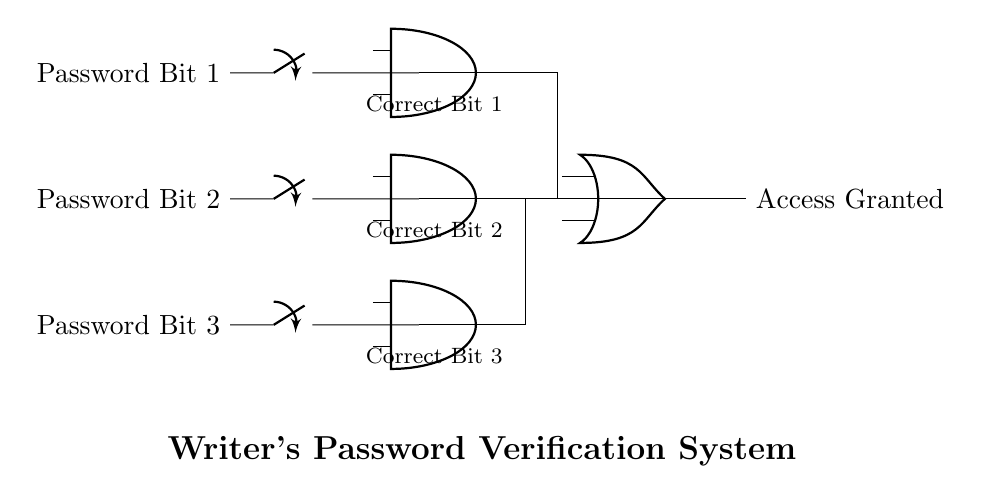What type of logic gates are used in this diagram? The diagram uses AND and OR gates as indicated by their shapes. Each gate is labeled, and their configuration shows a combination of these gates for the logic operation.
Answer: AND and OR How many input switches are there? There are three input switches representing Password Bit 1, Password Bit 2, and Password Bit 3, each positioned at different heights in the diagram.
Answer: Three What is the output of the circuit? The final output is labeled "Access Granted," indicating the result of the logical operations performed based on the input switches and the corresponding AND and OR gates.
Answer: Access Granted What is the function of the AND gates in this circuit? The AND gates take multiple inputs (the bits of the password) and produce a high output only when all the corresponding bits are set correctly, thus verifying each bit of the password.
Answer: Verify password bits How is the final output determined? The output is the result of combining the outputs of the AND gates through an OR gate. The OR gate outputs "Access Granted" if at least one of the AND gate outputs is high, meaning at least one password bit was correct.
Answer: Through an OR gate What conditions must be met for "Access Granted"? "Access Granted" occurs when at least one AND gate outputs high, which requires matching each corresponding correct password bit for the input switches. The conditions of the correct password bits must be satisfied for validation.
Answer: At least one correct password bit 